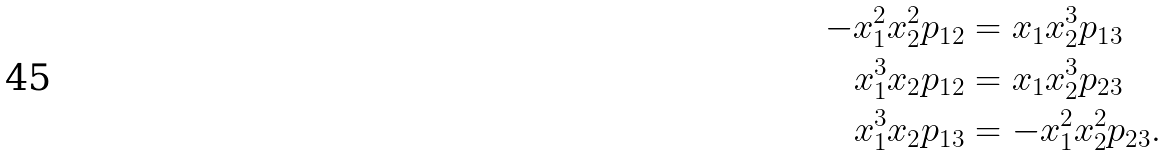<formula> <loc_0><loc_0><loc_500><loc_500>- x _ { 1 } ^ { 2 } x _ { 2 } ^ { 2 } p _ { 1 2 } & = x _ { 1 } x _ { 2 } ^ { 3 } p _ { 1 3 } \\ x _ { 1 } ^ { 3 } x _ { 2 } p _ { 1 2 } & = x _ { 1 } x _ { 2 } ^ { 3 } p _ { 2 3 } \\ x _ { 1 } ^ { 3 } x _ { 2 } p _ { 1 3 } & = - x _ { 1 } ^ { 2 } x _ { 2 } ^ { 2 } p _ { 2 3 } .</formula> 